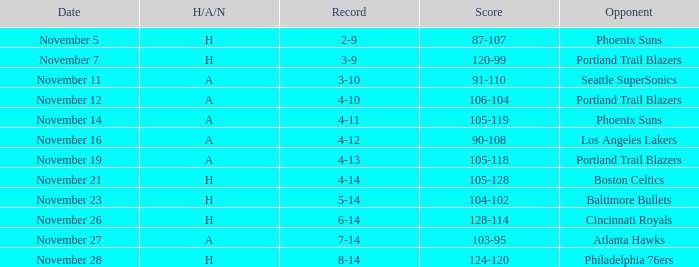On what Date was the Score 105-128? November 21. 